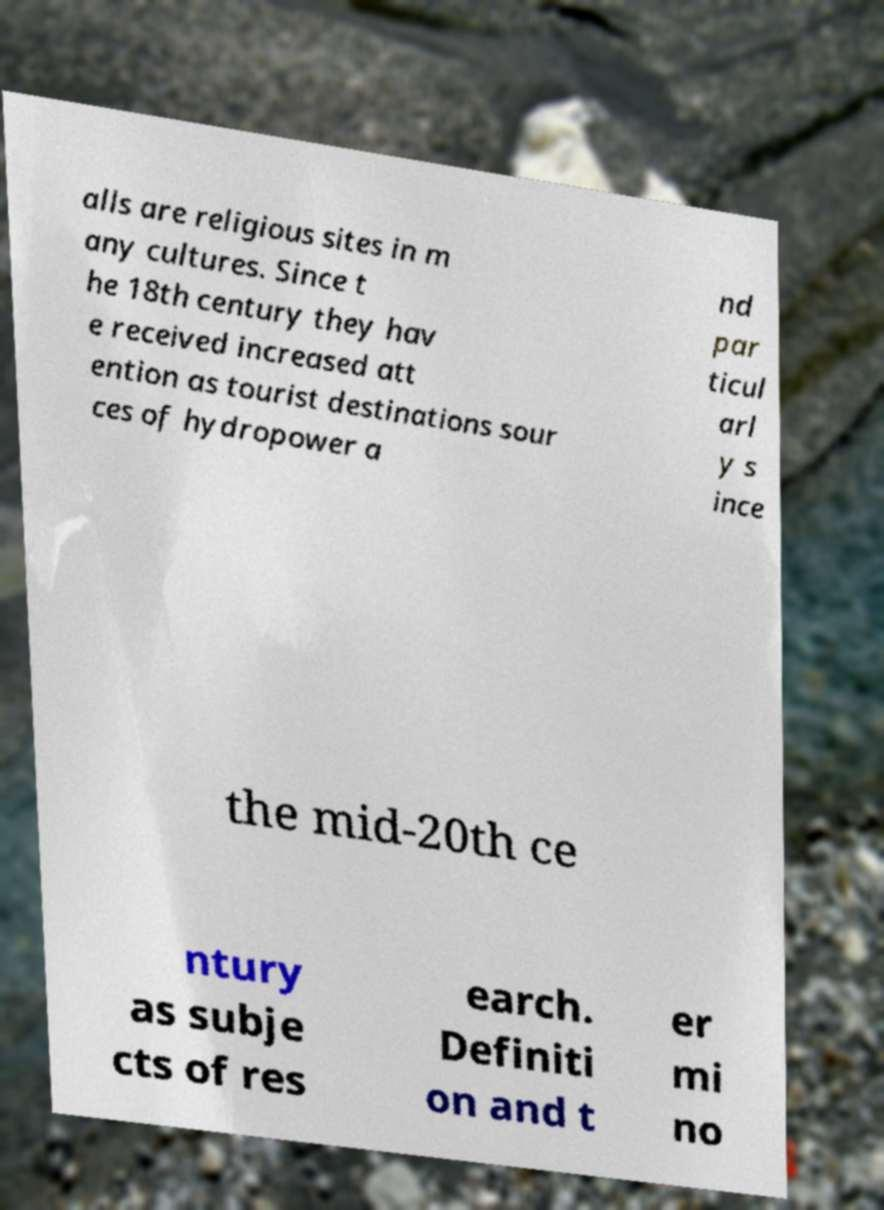Can you accurately transcribe the text from the provided image for me? alls are religious sites in m any cultures. Since t he 18th century they hav e received increased att ention as tourist destinations sour ces of hydropower a nd par ticul arl y s ince the mid-20th ce ntury as subje cts of res earch. Definiti on and t er mi no 